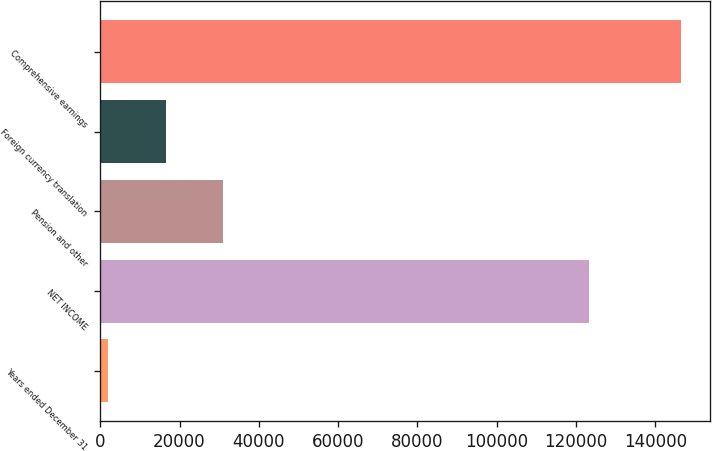Convert chart to OTSL. <chart><loc_0><loc_0><loc_500><loc_500><bar_chart><fcel>Years ended December 31<fcel>NET INCOME<fcel>Pension and other<fcel>Foreign currency translation<fcel>Comprehensive earnings<nl><fcel>2013<fcel>123330<fcel>30902.2<fcel>16457.6<fcel>146459<nl></chart> 